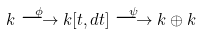Convert formula to latex. <formula><loc_0><loc_0><loc_500><loc_500>k \stackrel { \phi } \longrightarrow k [ t , d t ] \stackrel { \psi } \longrightarrow k \oplus k</formula> 